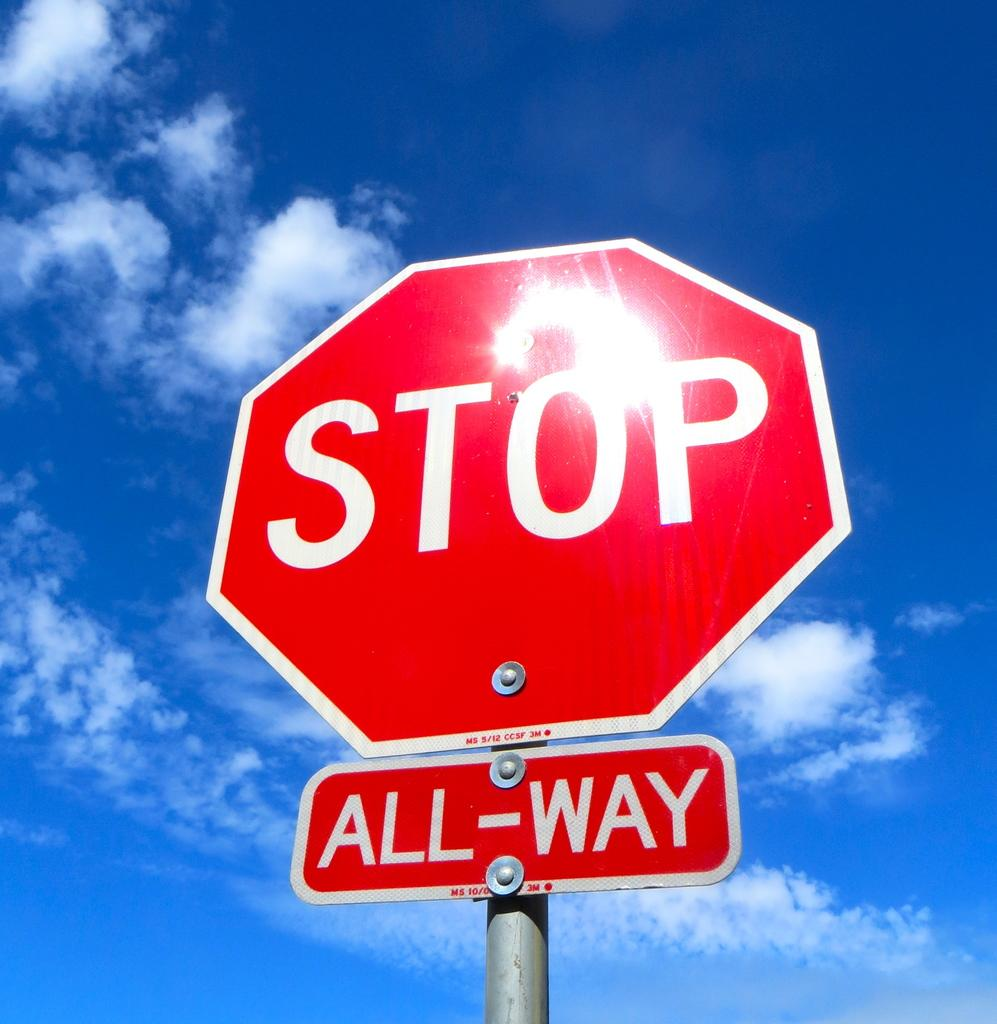<image>
Give a short and clear explanation of the subsequent image. A red stop sign with an All-Way bellow the sign in front of a blue sky 